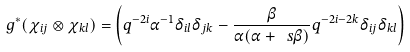Convert formula to latex. <formula><loc_0><loc_0><loc_500><loc_500>g ^ { * } ( \chi _ { i j } \otimes \chi _ { k l } ) = \left ( q ^ { - 2 i } \alpha ^ { - 1 } \delta _ { i l } \delta _ { j k } - \frac { \beta } { \alpha ( \alpha + \ s \beta ) } q ^ { - 2 i - 2 k } \delta _ { i j } \delta _ { k l } \right )</formula> 